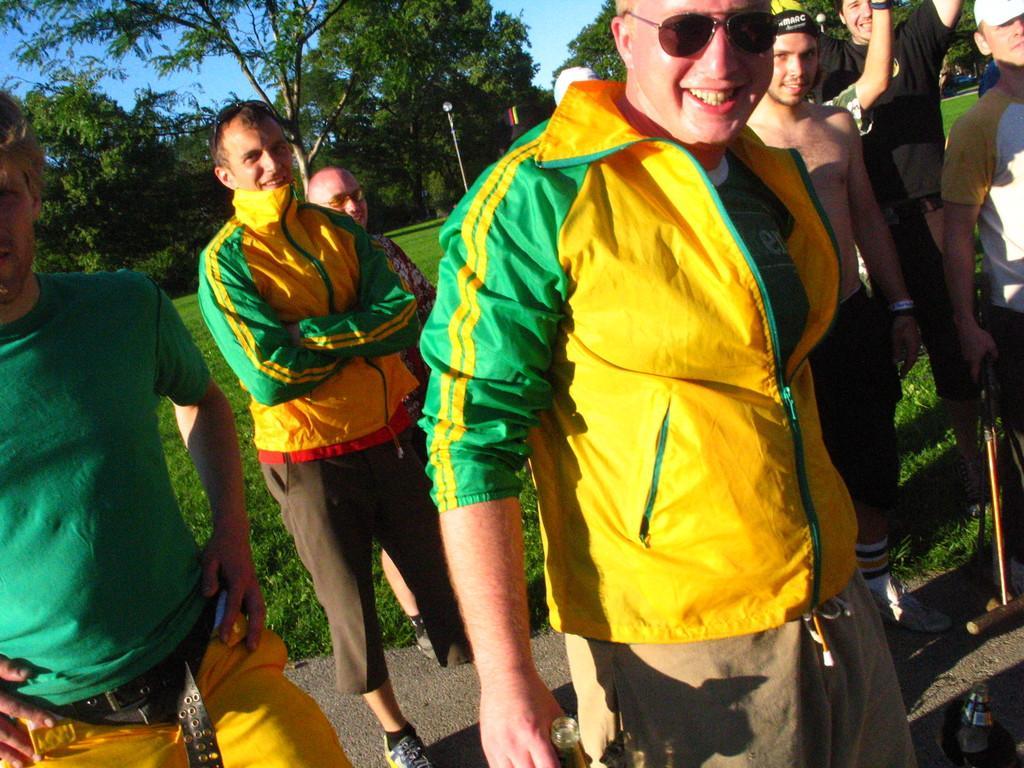How would you summarize this image in a sentence or two? In this picture we can see a group of people standing on the ground and smiling and in the background we can see poles, trees, sky. 